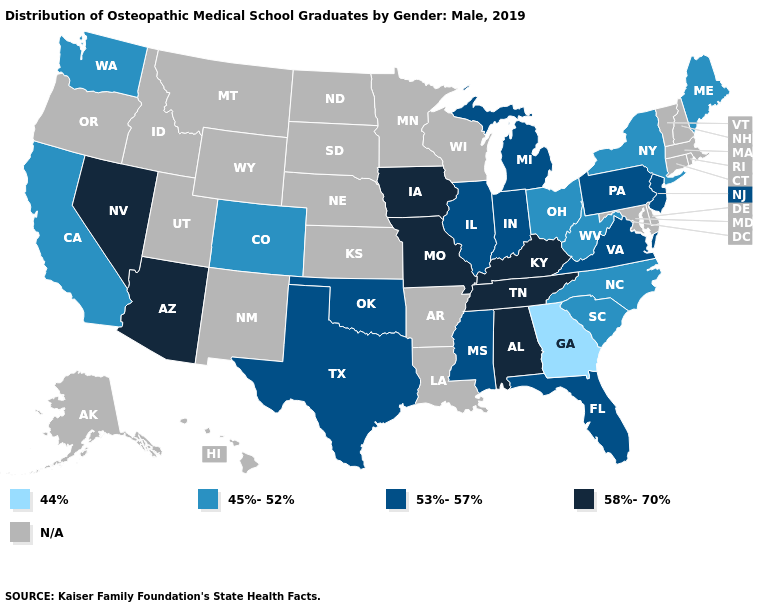Which states have the lowest value in the USA?
Quick response, please. Georgia. What is the value of North Carolina?
Keep it brief. 45%-52%. What is the lowest value in the Northeast?
Concise answer only. 45%-52%. What is the lowest value in the West?
Keep it brief. 45%-52%. Name the states that have a value in the range 58%-70%?
Short answer required. Alabama, Arizona, Iowa, Kentucky, Missouri, Nevada, Tennessee. Name the states that have a value in the range 44%?
Keep it brief. Georgia. What is the value of California?
Short answer required. 45%-52%. What is the value of Delaware?
Short answer required. N/A. Among the states that border Georgia , does North Carolina have the lowest value?
Give a very brief answer. Yes. What is the value of Vermont?
Quick response, please. N/A. What is the lowest value in the USA?
Write a very short answer. 44%. Is the legend a continuous bar?
Short answer required. No. Does the first symbol in the legend represent the smallest category?
Give a very brief answer. Yes. What is the lowest value in the MidWest?
Concise answer only. 45%-52%. 